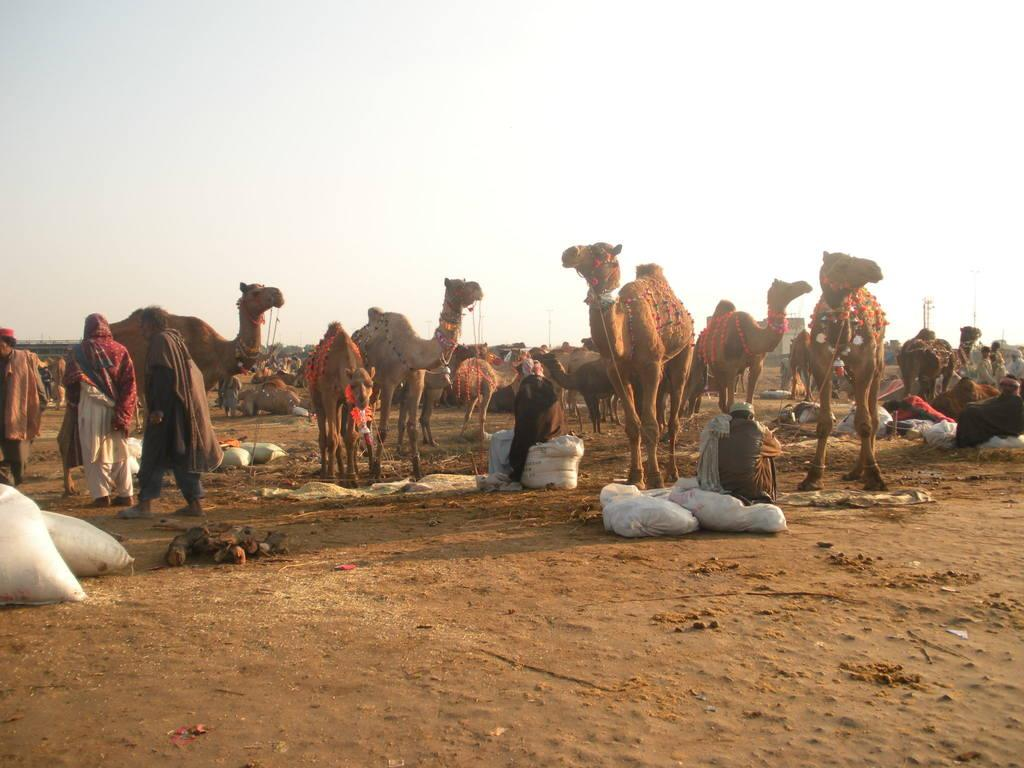What animals are present in the image? There are camels in the image. What are the people in the image doing? There are persons standing and sitting on the ground in the image. What can be seen in the sky in the image? The sky is clear and visible at the top of the image. What type of agreement can be seen being signed by the camels in the image? There are no agreements or camels signing anything in the image. Can you tell me how many balls are visible in the image? There are no balls present in the image. 